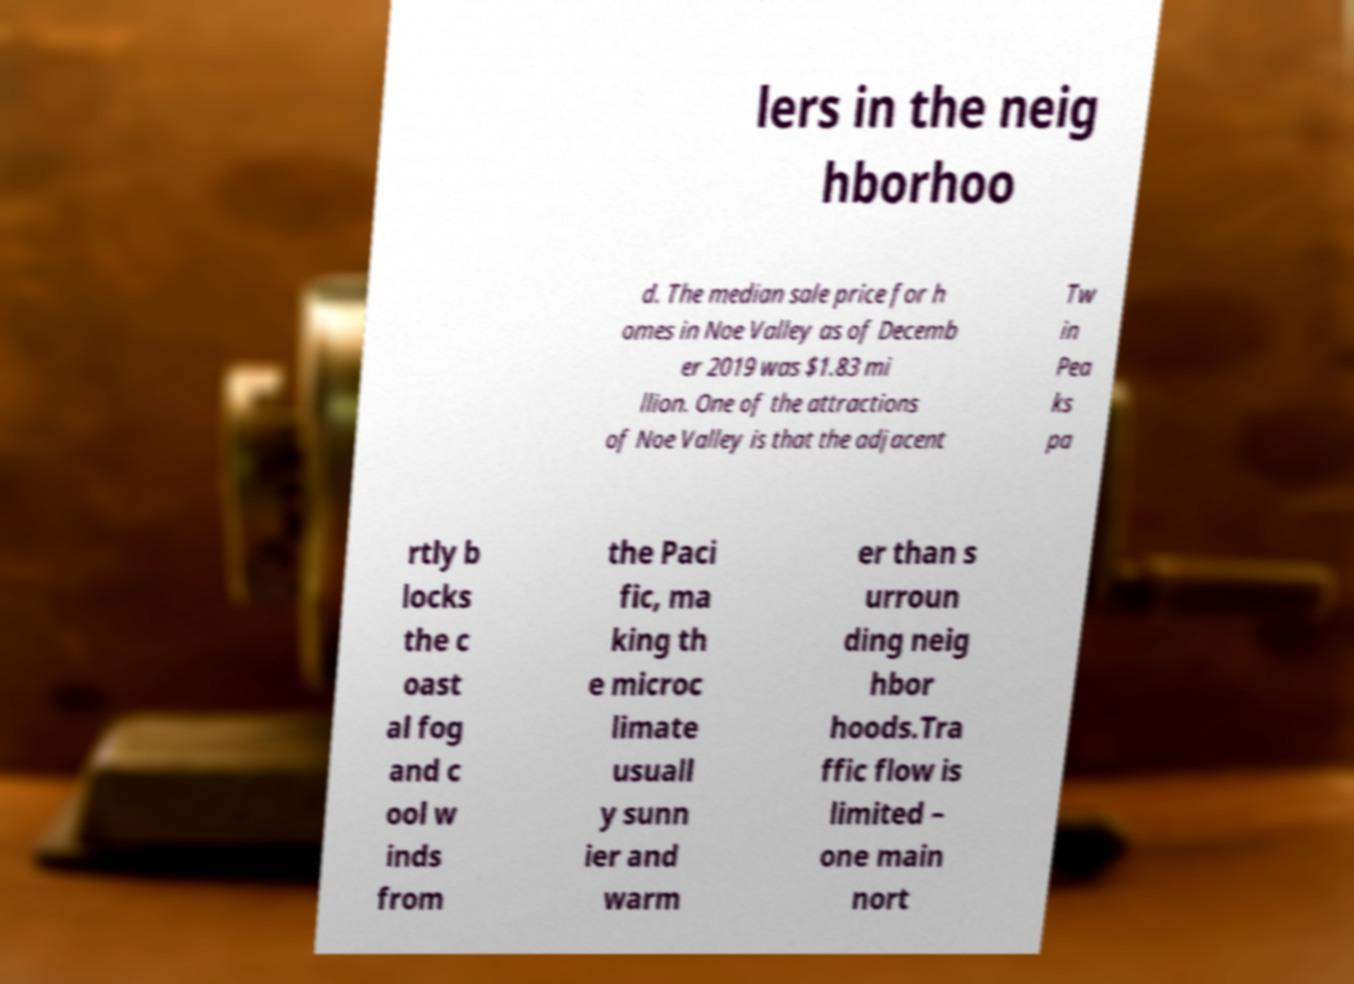For documentation purposes, I need the text within this image transcribed. Could you provide that? lers in the neig hborhoo d. The median sale price for h omes in Noe Valley as of Decemb er 2019 was $1.83 mi llion. One of the attractions of Noe Valley is that the adjacent Tw in Pea ks pa rtly b locks the c oast al fog and c ool w inds from the Paci fic, ma king th e microc limate usuall y sunn ier and warm er than s urroun ding neig hbor hoods.Tra ffic flow is limited – one main nort 